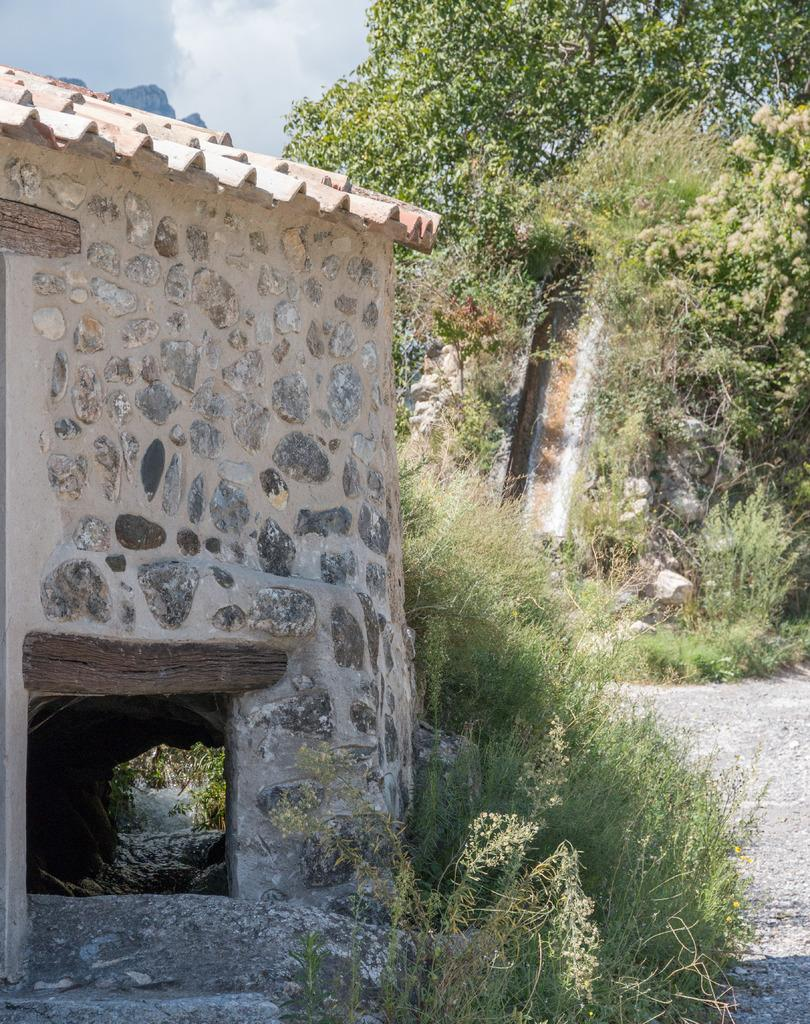What type of structure can be seen in the image? There is a shed in the image. What is on the ground near the shed? There are plants on the ground in the image. What other natural elements are present in the image? There are rocks and trees in the image. What can be seen in the background of the image? The sky is visible in the background of the image. What is the value of the artwork hanging on the shed in the image? There is no artwork hanging on the shed in the image, so it is not possible to determine its value. 